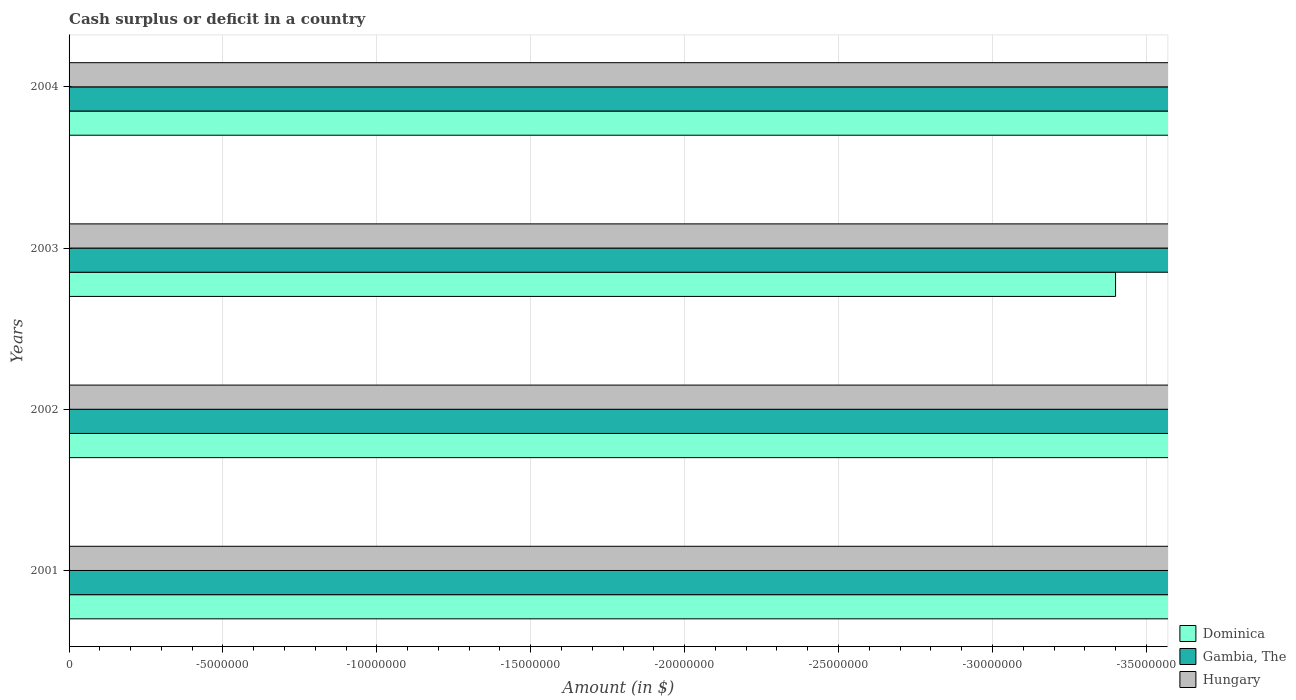How many different coloured bars are there?
Give a very brief answer. 0. Are the number of bars per tick equal to the number of legend labels?
Give a very brief answer. No. Are the number of bars on each tick of the Y-axis equal?
Offer a very short reply. Yes. How many bars are there on the 2nd tick from the bottom?
Provide a succinct answer. 0. What is the label of the 3rd group of bars from the top?
Make the answer very short. 2002. What is the total amount of cash surplus or deficit in Dominica in the graph?
Ensure brevity in your answer.  0. What is the difference between the amount of cash surplus or deficit in Hungary in 2004 and the amount of cash surplus or deficit in Gambia, The in 2003?
Ensure brevity in your answer.  0. In how many years, is the amount of cash surplus or deficit in Dominica greater than -5000000 $?
Provide a succinct answer. 0. Is it the case that in every year, the sum of the amount of cash surplus or deficit in Gambia, The and amount of cash surplus or deficit in Hungary is greater than the amount of cash surplus or deficit in Dominica?
Keep it short and to the point. No. Are all the bars in the graph horizontal?
Provide a short and direct response. Yes. How many years are there in the graph?
Ensure brevity in your answer.  4. Are the values on the major ticks of X-axis written in scientific E-notation?
Provide a short and direct response. No. Does the graph contain any zero values?
Your answer should be compact. Yes. Where does the legend appear in the graph?
Your answer should be very brief. Bottom right. How many legend labels are there?
Keep it short and to the point. 3. What is the title of the graph?
Ensure brevity in your answer.  Cash surplus or deficit in a country. Does "Tanzania" appear as one of the legend labels in the graph?
Give a very brief answer. No. What is the label or title of the X-axis?
Offer a very short reply. Amount (in $). What is the Amount (in $) in Dominica in 2001?
Offer a very short reply. 0. What is the Amount (in $) in Dominica in 2002?
Give a very brief answer. 0. What is the Amount (in $) in Hungary in 2002?
Give a very brief answer. 0. What is the Amount (in $) in Dominica in 2003?
Offer a terse response. 0. What is the Amount (in $) of Gambia, The in 2003?
Your answer should be compact. 0. What is the Amount (in $) of Gambia, The in 2004?
Ensure brevity in your answer.  0. What is the Amount (in $) in Hungary in 2004?
Your response must be concise. 0. What is the total Amount (in $) of Dominica in the graph?
Provide a short and direct response. 0. What is the total Amount (in $) of Gambia, The in the graph?
Provide a succinct answer. 0. What is the total Amount (in $) of Hungary in the graph?
Provide a short and direct response. 0. 